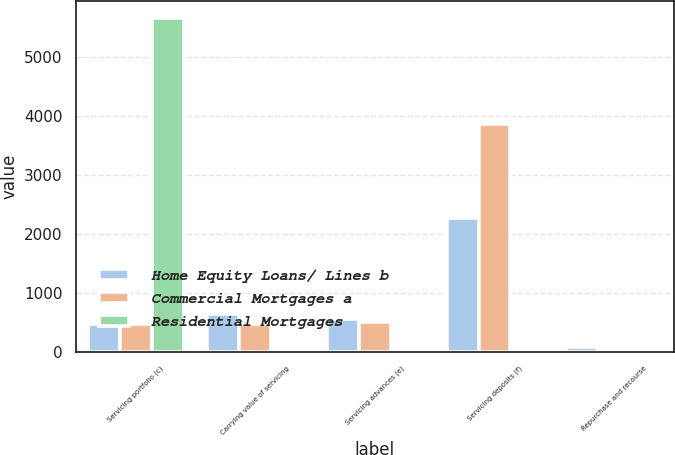Convert chart. <chart><loc_0><loc_0><loc_500><loc_500><stacked_bar_chart><ecel><fcel>Servicing portfolio (c)<fcel>Carrying value of servicing<fcel>Servicing advances (e)<fcel>Servicing deposits (f)<fcel>Repurchase and recourse<nl><fcel>Home Equity Loans/ Lines b<fcel>468<fcel>647<fcel>563<fcel>2264<fcel>83<nl><fcel>Commercial Mortgages a<fcel>468<fcel>468<fcel>510<fcel>3861<fcel>47<nl><fcel>Residential Mortgages<fcel>5661<fcel>1<fcel>8<fcel>38<fcel>47<nl></chart> 